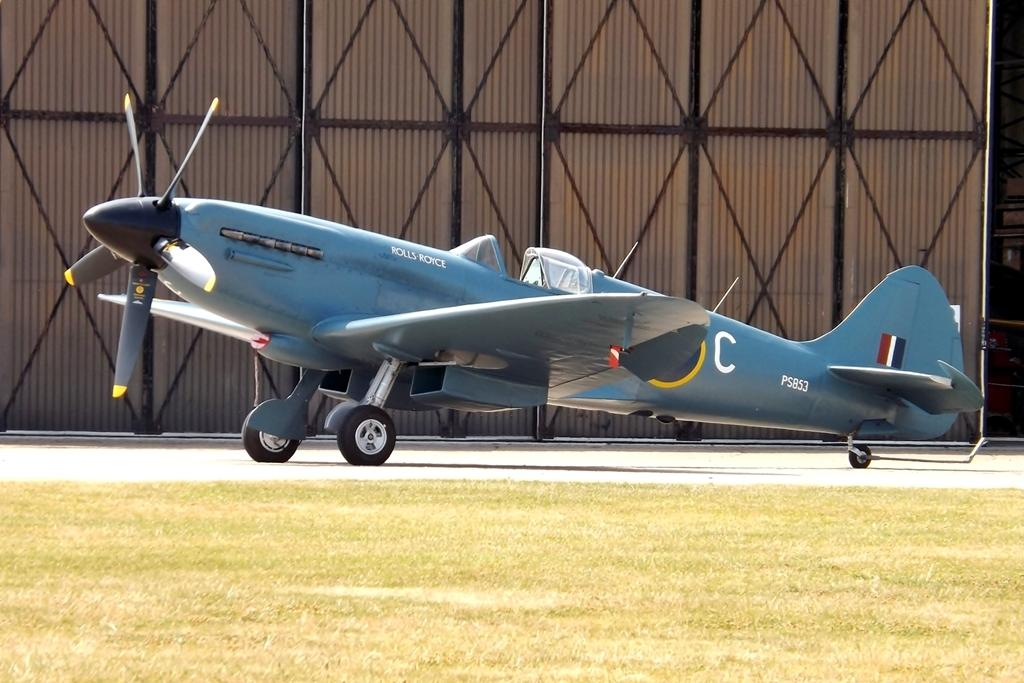What is the unusual object located on the road in the image? There is an airplane on the road in the image. What type of vegetation can be seen in the image? There is grass visible in the image. What can be seen in the background of the image? There is a wall, poles, and rods in the background of the image. What type of chair is placed on top of the airplane in the image? There is no chair present on top of the airplane in the image. Can you see any scissors being used to trim the grass in the image? There are no scissors visible in the image, and the grass does not appear to be trimmed. 